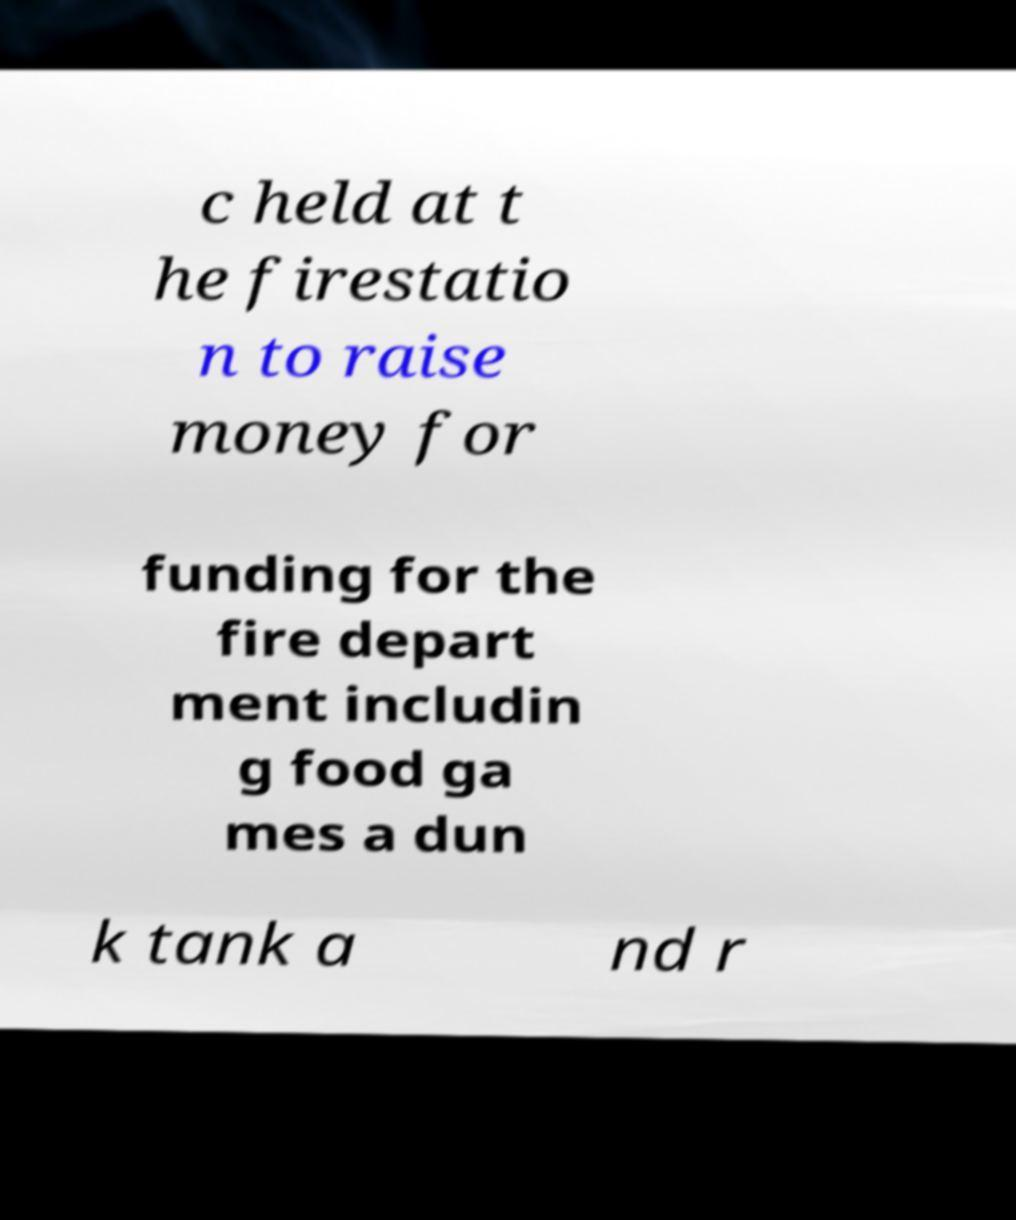I need the written content from this picture converted into text. Can you do that? c held at t he firestatio n to raise money for funding for the fire depart ment includin g food ga mes a dun k tank a nd r 